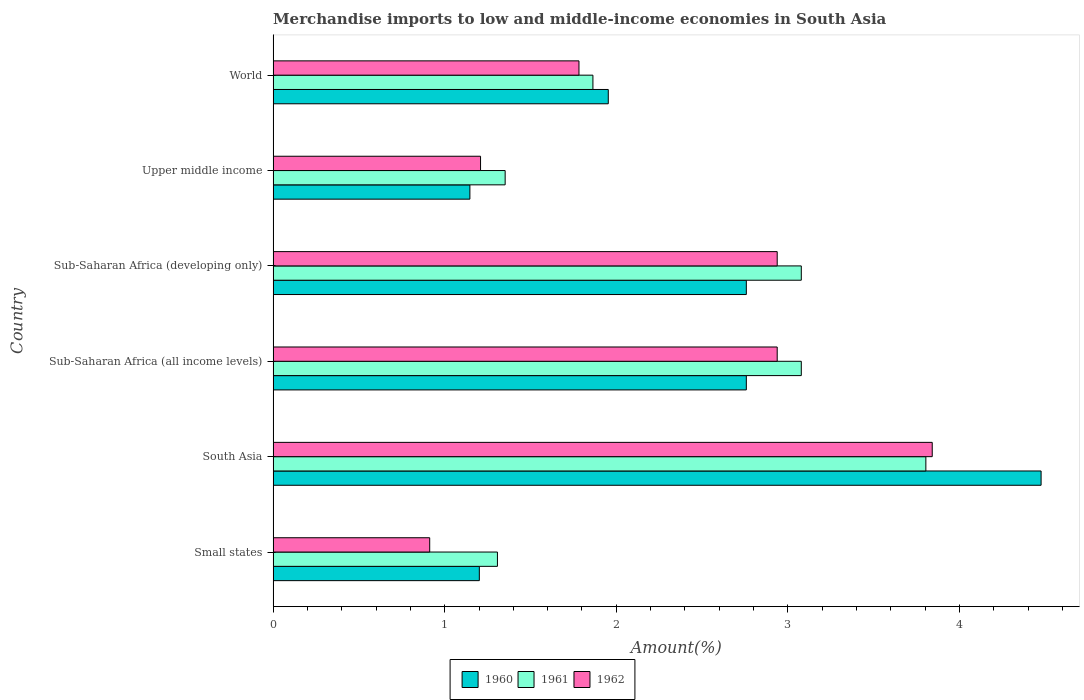How many groups of bars are there?
Provide a succinct answer. 6. Are the number of bars on each tick of the Y-axis equal?
Make the answer very short. Yes. How many bars are there on the 4th tick from the bottom?
Your answer should be compact. 3. What is the label of the 5th group of bars from the top?
Ensure brevity in your answer.  South Asia. In how many cases, is the number of bars for a given country not equal to the number of legend labels?
Provide a succinct answer. 0. What is the percentage of amount earned from merchandise imports in 1962 in World?
Your response must be concise. 1.78. Across all countries, what is the maximum percentage of amount earned from merchandise imports in 1960?
Keep it short and to the point. 4.48. Across all countries, what is the minimum percentage of amount earned from merchandise imports in 1962?
Offer a very short reply. 0.91. In which country was the percentage of amount earned from merchandise imports in 1962 minimum?
Keep it short and to the point. Small states. What is the total percentage of amount earned from merchandise imports in 1960 in the graph?
Provide a short and direct response. 14.29. What is the difference between the percentage of amount earned from merchandise imports in 1961 in Sub-Saharan Africa (all income levels) and that in World?
Your answer should be compact. 1.21. What is the difference between the percentage of amount earned from merchandise imports in 1962 in Sub-Saharan Africa (all income levels) and the percentage of amount earned from merchandise imports in 1961 in Small states?
Offer a terse response. 1.63. What is the average percentage of amount earned from merchandise imports in 1962 per country?
Provide a short and direct response. 2.27. What is the difference between the percentage of amount earned from merchandise imports in 1961 and percentage of amount earned from merchandise imports in 1962 in Sub-Saharan Africa (developing only)?
Provide a succinct answer. 0.14. In how many countries, is the percentage of amount earned from merchandise imports in 1962 greater than 3.8 %?
Keep it short and to the point. 1. What is the ratio of the percentage of amount earned from merchandise imports in 1960 in South Asia to that in World?
Provide a short and direct response. 2.29. Is the difference between the percentage of amount earned from merchandise imports in 1961 in Small states and World greater than the difference between the percentage of amount earned from merchandise imports in 1962 in Small states and World?
Your response must be concise. Yes. What is the difference between the highest and the second highest percentage of amount earned from merchandise imports in 1960?
Your answer should be very brief. 1.72. What is the difference between the highest and the lowest percentage of amount earned from merchandise imports in 1960?
Provide a succinct answer. 3.33. In how many countries, is the percentage of amount earned from merchandise imports in 1961 greater than the average percentage of amount earned from merchandise imports in 1961 taken over all countries?
Ensure brevity in your answer.  3. Is the sum of the percentage of amount earned from merchandise imports in 1960 in Small states and Sub-Saharan Africa (developing only) greater than the maximum percentage of amount earned from merchandise imports in 1962 across all countries?
Your answer should be very brief. Yes. What does the 3rd bar from the top in Sub-Saharan Africa (all income levels) represents?
Offer a terse response. 1960. How many bars are there?
Keep it short and to the point. 18. How many countries are there in the graph?
Your response must be concise. 6. What is the difference between two consecutive major ticks on the X-axis?
Make the answer very short. 1. Does the graph contain grids?
Your answer should be very brief. No. Where does the legend appear in the graph?
Your answer should be compact. Bottom center. What is the title of the graph?
Provide a succinct answer. Merchandise imports to low and middle-income economies in South Asia. Does "2001" appear as one of the legend labels in the graph?
Give a very brief answer. No. What is the label or title of the X-axis?
Your answer should be compact. Amount(%). What is the Amount(%) in 1960 in Small states?
Provide a short and direct response. 1.2. What is the Amount(%) in 1961 in Small states?
Provide a succinct answer. 1.31. What is the Amount(%) in 1962 in Small states?
Your response must be concise. 0.91. What is the Amount(%) in 1960 in South Asia?
Make the answer very short. 4.48. What is the Amount(%) of 1961 in South Asia?
Give a very brief answer. 3.8. What is the Amount(%) in 1962 in South Asia?
Offer a very short reply. 3.84. What is the Amount(%) in 1960 in Sub-Saharan Africa (all income levels)?
Ensure brevity in your answer.  2.76. What is the Amount(%) in 1961 in Sub-Saharan Africa (all income levels)?
Keep it short and to the point. 3.08. What is the Amount(%) in 1962 in Sub-Saharan Africa (all income levels)?
Your answer should be very brief. 2.94. What is the Amount(%) in 1960 in Sub-Saharan Africa (developing only)?
Offer a terse response. 2.76. What is the Amount(%) in 1961 in Sub-Saharan Africa (developing only)?
Give a very brief answer. 3.08. What is the Amount(%) of 1962 in Sub-Saharan Africa (developing only)?
Provide a succinct answer. 2.94. What is the Amount(%) in 1960 in Upper middle income?
Your answer should be very brief. 1.15. What is the Amount(%) of 1961 in Upper middle income?
Your answer should be very brief. 1.35. What is the Amount(%) of 1962 in Upper middle income?
Offer a terse response. 1.21. What is the Amount(%) in 1960 in World?
Provide a succinct answer. 1.95. What is the Amount(%) in 1961 in World?
Give a very brief answer. 1.86. What is the Amount(%) of 1962 in World?
Provide a succinct answer. 1.78. Across all countries, what is the maximum Amount(%) of 1960?
Provide a short and direct response. 4.48. Across all countries, what is the maximum Amount(%) of 1961?
Offer a very short reply. 3.8. Across all countries, what is the maximum Amount(%) of 1962?
Offer a very short reply. 3.84. Across all countries, what is the minimum Amount(%) of 1960?
Your response must be concise. 1.15. Across all countries, what is the minimum Amount(%) in 1961?
Your answer should be very brief. 1.31. Across all countries, what is the minimum Amount(%) in 1962?
Your answer should be very brief. 0.91. What is the total Amount(%) of 1960 in the graph?
Your response must be concise. 14.29. What is the total Amount(%) of 1961 in the graph?
Provide a succinct answer. 14.49. What is the total Amount(%) of 1962 in the graph?
Provide a succinct answer. 13.62. What is the difference between the Amount(%) of 1960 in Small states and that in South Asia?
Your response must be concise. -3.27. What is the difference between the Amount(%) in 1961 in Small states and that in South Asia?
Your answer should be very brief. -2.5. What is the difference between the Amount(%) in 1962 in Small states and that in South Asia?
Provide a short and direct response. -2.93. What is the difference between the Amount(%) of 1960 in Small states and that in Sub-Saharan Africa (all income levels)?
Offer a terse response. -1.56. What is the difference between the Amount(%) in 1961 in Small states and that in Sub-Saharan Africa (all income levels)?
Give a very brief answer. -1.77. What is the difference between the Amount(%) in 1962 in Small states and that in Sub-Saharan Africa (all income levels)?
Make the answer very short. -2.03. What is the difference between the Amount(%) of 1960 in Small states and that in Sub-Saharan Africa (developing only)?
Offer a very short reply. -1.56. What is the difference between the Amount(%) in 1961 in Small states and that in Sub-Saharan Africa (developing only)?
Your answer should be very brief. -1.77. What is the difference between the Amount(%) in 1962 in Small states and that in Sub-Saharan Africa (developing only)?
Provide a short and direct response. -2.03. What is the difference between the Amount(%) of 1960 in Small states and that in Upper middle income?
Give a very brief answer. 0.06. What is the difference between the Amount(%) in 1961 in Small states and that in Upper middle income?
Make the answer very short. -0.04. What is the difference between the Amount(%) of 1962 in Small states and that in Upper middle income?
Ensure brevity in your answer.  -0.3. What is the difference between the Amount(%) in 1960 in Small states and that in World?
Your answer should be very brief. -0.75. What is the difference between the Amount(%) of 1961 in Small states and that in World?
Offer a terse response. -0.56. What is the difference between the Amount(%) in 1962 in Small states and that in World?
Make the answer very short. -0.87. What is the difference between the Amount(%) of 1960 in South Asia and that in Sub-Saharan Africa (all income levels)?
Offer a terse response. 1.72. What is the difference between the Amount(%) in 1961 in South Asia and that in Sub-Saharan Africa (all income levels)?
Give a very brief answer. 0.73. What is the difference between the Amount(%) of 1962 in South Asia and that in Sub-Saharan Africa (all income levels)?
Your response must be concise. 0.9. What is the difference between the Amount(%) in 1960 in South Asia and that in Sub-Saharan Africa (developing only)?
Give a very brief answer. 1.72. What is the difference between the Amount(%) of 1961 in South Asia and that in Sub-Saharan Africa (developing only)?
Your answer should be compact. 0.73. What is the difference between the Amount(%) in 1962 in South Asia and that in Sub-Saharan Africa (developing only)?
Your answer should be very brief. 0.9. What is the difference between the Amount(%) of 1960 in South Asia and that in Upper middle income?
Offer a very short reply. 3.33. What is the difference between the Amount(%) of 1961 in South Asia and that in Upper middle income?
Provide a short and direct response. 2.45. What is the difference between the Amount(%) in 1962 in South Asia and that in Upper middle income?
Make the answer very short. 2.63. What is the difference between the Amount(%) of 1960 in South Asia and that in World?
Your answer should be very brief. 2.52. What is the difference between the Amount(%) in 1961 in South Asia and that in World?
Ensure brevity in your answer.  1.94. What is the difference between the Amount(%) of 1962 in South Asia and that in World?
Offer a terse response. 2.06. What is the difference between the Amount(%) in 1960 in Sub-Saharan Africa (all income levels) and that in Upper middle income?
Make the answer very short. 1.61. What is the difference between the Amount(%) of 1961 in Sub-Saharan Africa (all income levels) and that in Upper middle income?
Give a very brief answer. 1.73. What is the difference between the Amount(%) in 1962 in Sub-Saharan Africa (all income levels) and that in Upper middle income?
Offer a terse response. 1.73. What is the difference between the Amount(%) of 1960 in Sub-Saharan Africa (all income levels) and that in World?
Offer a terse response. 0.8. What is the difference between the Amount(%) in 1961 in Sub-Saharan Africa (all income levels) and that in World?
Make the answer very short. 1.21. What is the difference between the Amount(%) of 1962 in Sub-Saharan Africa (all income levels) and that in World?
Your response must be concise. 1.16. What is the difference between the Amount(%) in 1960 in Sub-Saharan Africa (developing only) and that in Upper middle income?
Your answer should be very brief. 1.61. What is the difference between the Amount(%) of 1961 in Sub-Saharan Africa (developing only) and that in Upper middle income?
Keep it short and to the point. 1.73. What is the difference between the Amount(%) of 1962 in Sub-Saharan Africa (developing only) and that in Upper middle income?
Ensure brevity in your answer.  1.73. What is the difference between the Amount(%) in 1960 in Sub-Saharan Africa (developing only) and that in World?
Provide a short and direct response. 0.8. What is the difference between the Amount(%) in 1961 in Sub-Saharan Africa (developing only) and that in World?
Provide a short and direct response. 1.21. What is the difference between the Amount(%) in 1962 in Sub-Saharan Africa (developing only) and that in World?
Provide a short and direct response. 1.16. What is the difference between the Amount(%) of 1960 in Upper middle income and that in World?
Your response must be concise. -0.81. What is the difference between the Amount(%) in 1961 in Upper middle income and that in World?
Your answer should be compact. -0.51. What is the difference between the Amount(%) in 1962 in Upper middle income and that in World?
Provide a short and direct response. -0.57. What is the difference between the Amount(%) in 1960 in Small states and the Amount(%) in 1961 in South Asia?
Provide a succinct answer. -2.6. What is the difference between the Amount(%) of 1960 in Small states and the Amount(%) of 1962 in South Asia?
Give a very brief answer. -2.64. What is the difference between the Amount(%) in 1961 in Small states and the Amount(%) in 1962 in South Asia?
Keep it short and to the point. -2.53. What is the difference between the Amount(%) of 1960 in Small states and the Amount(%) of 1961 in Sub-Saharan Africa (all income levels)?
Make the answer very short. -1.88. What is the difference between the Amount(%) in 1960 in Small states and the Amount(%) in 1962 in Sub-Saharan Africa (all income levels)?
Provide a succinct answer. -1.74. What is the difference between the Amount(%) in 1961 in Small states and the Amount(%) in 1962 in Sub-Saharan Africa (all income levels)?
Ensure brevity in your answer.  -1.63. What is the difference between the Amount(%) of 1960 in Small states and the Amount(%) of 1961 in Sub-Saharan Africa (developing only)?
Your answer should be very brief. -1.88. What is the difference between the Amount(%) of 1960 in Small states and the Amount(%) of 1962 in Sub-Saharan Africa (developing only)?
Your response must be concise. -1.74. What is the difference between the Amount(%) in 1961 in Small states and the Amount(%) in 1962 in Sub-Saharan Africa (developing only)?
Ensure brevity in your answer.  -1.63. What is the difference between the Amount(%) in 1960 in Small states and the Amount(%) in 1961 in Upper middle income?
Offer a terse response. -0.15. What is the difference between the Amount(%) in 1960 in Small states and the Amount(%) in 1962 in Upper middle income?
Keep it short and to the point. -0.01. What is the difference between the Amount(%) of 1961 in Small states and the Amount(%) of 1962 in Upper middle income?
Make the answer very short. 0.1. What is the difference between the Amount(%) of 1960 in Small states and the Amount(%) of 1961 in World?
Give a very brief answer. -0.66. What is the difference between the Amount(%) in 1960 in Small states and the Amount(%) in 1962 in World?
Your answer should be very brief. -0.58. What is the difference between the Amount(%) of 1961 in Small states and the Amount(%) of 1962 in World?
Your response must be concise. -0.48. What is the difference between the Amount(%) of 1960 in South Asia and the Amount(%) of 1961 in Sub-Saharan Africa (all income levels)?
Your answer should be compact. 1.4. What is the difference between the Amount(%) of 1960 in South Asia and the Amount(%) of 1962 in Sub-Saharan Africa (all income levels)?
Provide a succinct answer. 1.54. What is the difference between the Amount(%) in 1961 in South Asia and the Amount(%) in 1962 in Sub-Saharan Africa (all income levels)?
Provide a short and direct response. 0.87. What is the difference between the Amount(%) of 1960 in South Asia and the Amount(%) of 1961 in Sub-Saharan Africa (developing only)?
Offer a very short reply. 1.4. What is the difference between the Amount(%) of 1960 in South Asia and the Amount(%) of 1962 in Sub-Saharan Africa (developing only)?
Provide a succinct answer. 1.54. What is the difference between the Amount(%) of 1961 in South Asia and the Amount(%) of 1962 in Sub-Saharan Africa (developing only)?
Provide a succinct answer. 0.87. What is the difference between the Amount(%) in 1960 in South Asia and the Amount(%) in 1961 in Upper middle income?
Provide a succinct answer. 3.12. What is the difference between the Amount(%) in 1960 in South Asia and the Amount(%) in 1962 in Upper middle income?
Your answer should be compact. 3.27. What is the difference between the Amount(%) in 1961 in South Asia and the Amount(%) in 1962 in Upper middle income?
Offer a very short reply. 2.6. What is the difference between the Amount(%) of 1960 in South Asia and the Amount(%) of 1961 in World?
Offer a very short reply. 2.61. What is the difference between the Amount(%) of 1960 in South Asia and the Amount(%) of 1962 in World?
Your response must be concise. 2.69. What is the difference between the Amount(%) of 1961 in South Asia and the Amount(%) of 1962 in World?
Provide a succinct answer. 2.02. What is the difference between the Amount(%) in 1960 in Sub-Saharan Africa (all income levels) and the Amount(%) in 1961 in Sub-Saharan Africa (developing only)?
Keep it short and to the point. -0.32. What is the difference between the Amount(%) in 1960 in Sub-Saharan Africa (all income levels) and the Amount(%) in 1962 in Sub-Saharan Africa (developing only)?
Offer a terse response. -0.18. What is the difference between the Amount(%) of 1961 in Sub-Saharan Africa (all income levels) and the Amount(%) of 1962 in Sub-Saharan Africa (developing only)?
Offer a very short reply. 0.14. What is the difference between the Amount(%) of 1960 in Sub-Saharan Africa (all income levels) and the Amount(%) of 1961 in Upper middle income?
Offer a very short reply. 1.41. What is the difference between the Amount(%) of 1960 in Sub-Saharan Africa (all income levels) and the Amount(%) of 1962 in Upper middle income?
Offer a terse response. 1.55. What is the difference between the Amount(%) in 1961 in Sub-Saharan Africa (all income levels) and the Amount(%) in 1962 in Upper middle income?
Your response must be concise. 1.87. What is the difference between the Amount(%) in 1960 in Sub-Saharan Africa (all income levels) and the Amount(%) in 1961 in World?
Provide a short and direct response. 0.89. What is the difference between the Amount(%) in 1960 in Sub-Saharan Africa (all income levels) and the Amount(%) in 1962 in World?
Your response must be concise. 0.98. What is the difference between the Amount(%) of 1961 in Sub-Saharan Africa (all income levels) and the Amount(%) of 1962 in World?
Your answer should be very brief. 1.3. What is the difference between the Amount(%) in 1960 in Sub-Saharan Africa (developing only) and the Amount(%) in 1961 in Upper middle income?
Keep it short and to the point. 1.41. What is the difference between the Amount(%) in 1960 in Sub-Saharan Africa (developing only) and the Amount(%) in 1962 in Upper middle income?
Keep it short and to the point. 1.55. What is the difference between the Amount(%) in 1961 in Sub-Saharan Africa (developing only) and the Amount(%) in 1962 in Upper middle income?
Provide a short and direct response. 1.87. What is the difference between the Amount(%) of 1960 in Sub-Saharan Africa (developing only) and the Amount(%) of 1961 in World?
Your answer should be very brief. 0.89. What is the difference between the Amount(%) of 1960 in Sub-Saharan Africa (developing only) and the Amount(%) of 1962 in World?
Offer a very short reply. 0.98. What is the difference between the Amount(%) in 1961 in Sub-Saharan Africa (developing only) and the Amount(%) in 1962 in World?
Offer a very short reply. 1.3. What is the difference between the Amount(%) of 1960 in Upper middle income and the Amount(%) of 1961 in World?
Your response must be concise. -0.72. What is the difference between the Amount(%) of 1960 in Upper middle income and the Amount(%) of 1962 in World?
Your answer should be very brief. -0.64. What is the difference between the Amount(%) in 1961 in Upper middle income and the Amount(%) in 1962 in World?
Provide a succinct answer. -0.43. What is the average Amount(%) of 1960 per country?
Provide a short and direct response. 2.38. What is the average Amount(%) of 1961 per country?
Your answer should be compact. 2.41. What is the average Amount(%) of 1962 per country?
Ensure brevity in your answer.  2.27. What is the difference between the Amount(%) in 1960 and Amount(%) in 1961 in Small states?
Your answer should be very brief. -0.11. What is the difference between the Amount(%) in 1960 and Amount(%) in 1962 in Small states?
Make the answer very short. 0.29. What is the difference between the Amount(%) of 1961 and Amount(%) of 1962 in Small states?
Provide a succinct answer. 0.39. What is the difference between the Amount(%) in 1960 and Amount(%) in 1961 in South Asia?
Your answer should be very brief. 0.67. What is the difference between the Amount(%) of 1960 and Amount(%) of 1962 in South Asia?
Keep it short and to the point. 0.63. What is the difference between the Amount(%) in 1961 and Amount(%) in 1962 in South Asia?
Your answer should be very brief. -0.04. What is the difference between the Amount(%) of 1960 and Amount(%) of 1961 in Sub-Saharan Africa (all income levels)?
Keep it short and to the point. -0.32. What is the difference between the Amount(%) of 1960 and Amount(%) of 1962 in Sub-Saharan Africa (all income levels)?
Your answer should be compact. -0.18. What is the difference between the Amount(%) in 1961 and Amount(%) in 1962 in Sub-Saharan Africa (all income levels)?
Keep it short and to the point. 0.14. What is the difference between the Amount(%) in 1960 and Amount(%) in 1961 in Sub-Saharan Africa (developing only)?
Your response must be concise. -0.32. What is the difference between the Amount(%) in 1960 and Amount(%) in 1962 in Sub-Saharan Africa (developing only)?
Offer a terse response. -0.18. What is the difference between the Amount(%) in 1961 and Amount(%) in 1962 in Sub-Saharan Africa (developing only)?
Offer a terse response. 0.14. What is the difference between the Amount(%) of 1960 and Amount(%) of 1961 in Upper middle income?
Provide a succinct answer. -0.21. What is the difference between the Amount(%) in 1960 and Amount(%) in 1962 in Upper middle income?
Offer a terse response. -0.06. What is the difference between the Amount(%) of 1961 and Amount(%) of 1962 in Upper middle income?
Make the answer very short. 0.14. What is the difference between the Amount(%) of 1960 and Amount(%) of 1961 in World?
Ensure brevity in your answer.  0.09. What is the difference between the Amount(%) in 1960 and Amount(%) in 1962 in World?
Give a very brief answer. 0.17. What is the difference between the Amount(%) of 1961 and Amount(%) of 1962 in World?
Your answer should be compact. 0.08. What is the ratio of the Amount(%) in 1960 in Small states to that in South Asia?
Offer a terse response. 0.27. What is the ratio of the Amount(%) in 1961 in Small states to that in South Asia?
Your answer should be compact. 0.34. What is the ratio of the Amount(%) of 1962 in Small states to that in South Asia?
Your answer should be very brief. 0.24. What is the ratio of the Amount(%) of 1960 in Small states to that in Sub-Saharan Africa (all income levels)?
Your answer should be compact. 0.44. What is the ratio of the Amount(%) in 1961 in Small states to that in Sub-Saharan Africa (all income levels)?
Ensure brevity in your answer.  0.42. What is the ratio of the Amount(%) of 1962 in Small states to that in Sub-Saharan Africa (all income levels)?
Provide a succinct answer. 0.31. What is the ratio of the Amount(%) in 1960 in Small states to that in Sub-Saharan Africa (developing only)?
Keep it short and to the point. 0.44. What is the ratio of the Amount(%) of 1961 in Small states to that in Sub-Saharan Africa (developing only)?
Offer a very short reply. 0.42. What is the ratio of the Amount(%) of 1962 in Small states to that in Sub-Saharan Africa (developing only)?
Provide a short and direct response. 0.31. What is the ratio of the Amount(%) of 1960 in Small states to that in Upper middle income?
Your answer should be compact. 1.05. What is the ratio of the Amount(%) in 1961 in Small states to that in Upper middle income?
Offer a terse response. 0.97. What is the ratio of the Amount(%) of 1962 in Small states to that in Upper middle income?
Offer a very short reply. 0.75. What is the ratio of the Amount(%) in 1960 in Small states to that in World?
Offer a very short reply. 0.62. What is the ratio of the Amount(%) of 1961 in Small states to that in World?
Provide a succinct answer. 0.7. What is the ratio of the Amount(%) in 1962 in Small states to that in World?
Offer a very short reply. 0.51. What is the ratio of the Amount(%) in 1960 in South Asia to that in Sub-Saharan Africa (all income levels)?
Provide a short and direct response. 1.62. What is the ratio of the Amount(%) of 1961 in South Asia to that in Sub-Saharan Africa (all income levels)?
Ensure brevity in your answer.  1.24. What is the ratio of the Amount(%) of 1962 in South Asia to that in Sub-Saharan Africa (all income levels)?
Keep it short and to the point. 1.31. What is the ratio of the Amount(%) of 1960 in South Asia to that in Sub-Saharan Africa (developing only)?
Provide a short and direct response. 1.62. What is the ratio of the Amount(%) of 1961 in South Asia to that in Sub-Saharan Africa (developing only)?
Ensure brevity in your answer.  1.24. What is the ratio of the Amount(%) of 1962 in South Asia to that in Sub-Saharan Africa (developing only)?
Offer a very short reply. 1.31. What is the ratio of the Amount(%) in 1960 in South Asia to that in Upper middle income?
Keep it short and to the point. 3.9. What is the ratio of the Amount(%) of 1961 in South Asia to that in Upper middle income?
Offer a very short reply. 2.81. What is the ratio of the Amount(%) in 1962 in South Asia to that in Upper middle income?
Your answer should be compact. 3.18. What is the ratio of the Amount(%) of 1960 in South Asia to that in World?
Your response must be concise. 2.29. What is the ratio of the Amount(%) in 1961 in South Asia to that in World?
Provide a succinct answer. 2.04. What is the ratio of the Amount(%) of 1962 in South Asia to that in World?
Provide a succinct answer. 2.16. What is the ratio of the Amount(%) in 1961 in Sub-Saharan Africa (all income levels) to that in Sub-Saharan Africa (developing only)?
Make the answer very short. 1. What is the ratio of the Amount(%) of 1960 in Sub-Saharan Africa (all income levels) to that in Upper middle income?
Make the answer very short. 2.4. What is the ratio of the Amount(%) in 1961 in Sub-Saharan Africa (all income levels) to that in Upper middle income?
Provide a succinct answer. 2.28. What is the ratio of the Amount(%) in 1962 in Sub-Saharan Africa (all income levels) to that in Upper middle income?
Provide a short and direct response. 2.43. What is the ratio of the Amount(%) of 1960 in Sub-Saharan Africa (all income levels) to that in World?
Make the answer very short. 1.41. What is the ratio of the Amount(%) of 1961 in Sub-Saharan Africa (all income levels) to that in World?
Give a very brief answer. 1.65. What is the ratio of the Amount(%) in 1962 in Sub-Saharan Africa (all income levels) to that in World?
Your answer should be compact. 1.65. What is the ratio of the Amount(%) of 1960 in Sub-Saharan Africa (developing only) to that in Upper middle income?
Give a very brief answer. 2.4. What is the ratio of the Amount(%) of 1961 in Sub-Saharan Africa (developing only) to that in Upper middle income?
Your answer should be very brief. 2.28. What is the ratio of the Amount(%) in 1962 in Sub-Saharan Africa (developing only) to that in Upper middle income?
Provide a short and direct response. 2.43. What is the ratio of the Amount(%) in 1960 in Sub-Saharan Africa (developing only) to that in World?
Give a very brief answer. 1.41. What is the ratio of the Amount(%) in 1961 in Sub-Saharan Africa (developing only) to that in World?
Offer a terse response. 1.65. What is the ratio of the Amount(%) of 1962 in Sub-Saharan Africa (developing only) to that in World?
Provide a short and direct response. 1.65. What is the ratio of the Amount(%) of 1960 in Upper middle income to that in World?
Ensure brevity in your answer.  0.59. What is the ratio of the Amount(%) of 1961 in Upper middle income to that in World?
Provide a short and direct response. 0.73. What is the ratio of the Amount(%) in 1962 in Upper middle income to that in World?
Provide a succinct answer. 0.68. What is the difference between the highest and the second highest Amount(%) in 1960?
Make the answer very short. 1.72. What is the difference between the highest and the second highest Amount(%) in 1961?
Provide a short and direct response. 0.73. What is the difference between the highest and the second highest Amount(%) of 1962?
Make the answer very short. 0.9. What is the difference between the highest and the lowest Amount(%) of 1960?
Offer a terse response. 3.33. What is the difference between the highest and the lowest Amount(%) of 1961?
Offer a very short reply. 2.5. What is the difference between the highest and the lowest Amount(%) in 1962?
Provide a short and direct response. 2.93. 